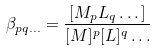<formula> <loc_0><loc_0><loc_500><loc_500>\beta _ { p q \dots } = \frac { [ M _ { p } L _ { q } \dots ] } { [ M ] ^ { p } [ L ] ^ { q } \dots }</formula> 